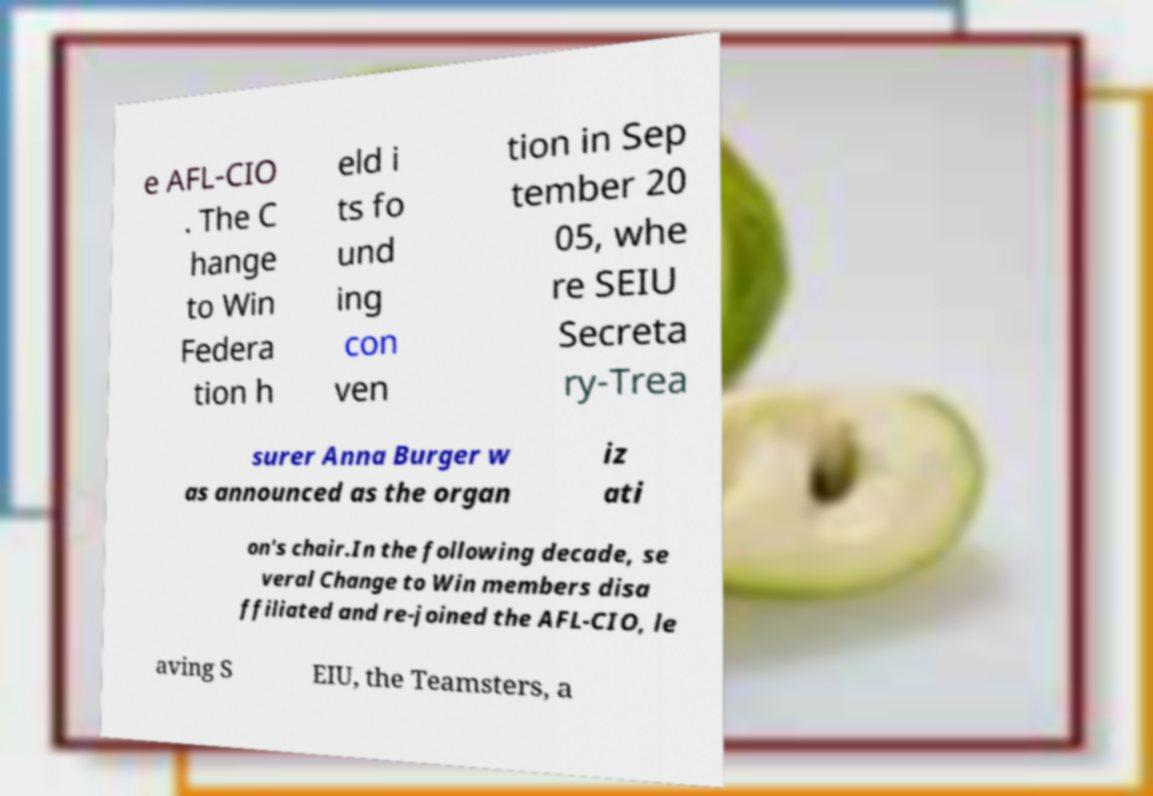I need the written content from this picture converted into text. Can you do that? e AFL-CIO . The C hange to Win Federa tion h eld i ts fo und ing con ven tion in Sep tember 20 05, whe re SEIU Secreta ry-Trea surer Anna Burger w as announced as the organ iz ati on's chair.In the following decade, se veral Change to Win members disa ffiliated and re-joined the AFL-CIO, le aving S EIU, the Teamsters, a 